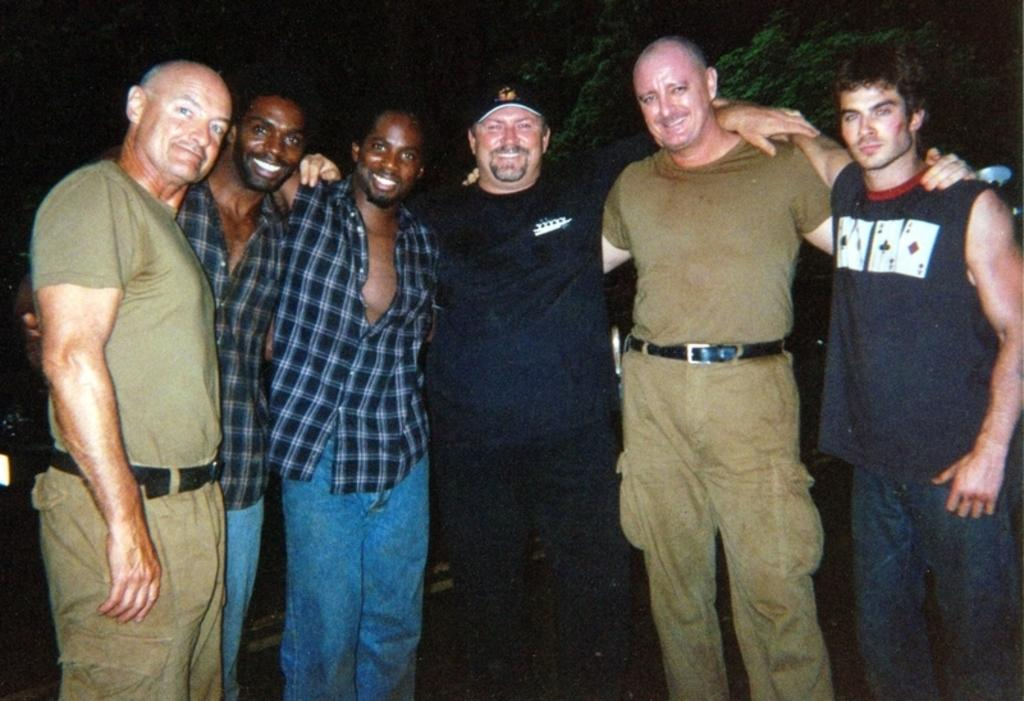What is happening with the people in the image? The people in the image are standing and smiling. What can be seen in the background of the image? There are green color trees in the background of the image. What type of meat is being grilled in the image? There is no meat or grill present in the image; it features people standing and smiling with green trees in the background. 